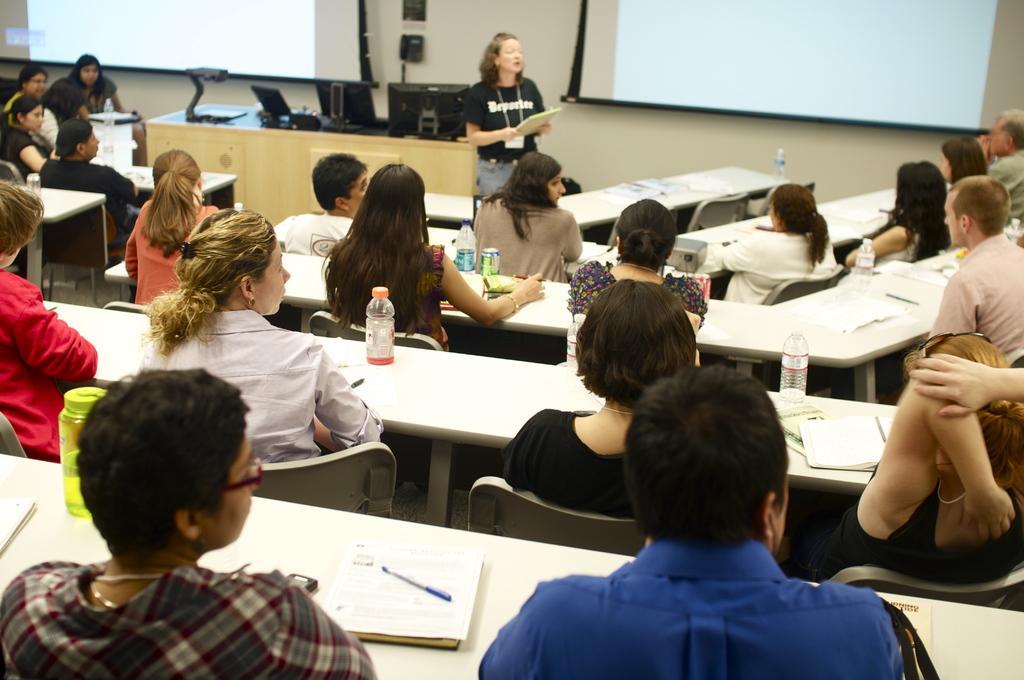Describe this image in one or two sentences. This is a picture taken in a classroom. In the foreground of the picture there are people, bottles, books, benches, chairs and pens. The background is blurred. In the background there are projector screens, desktops, people, cables and other objects. In the background it is wall painted white. 